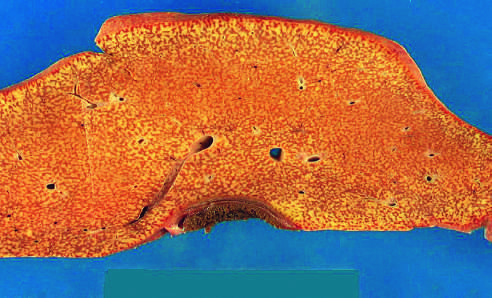what is small (700 g), bile-stained, soft, and congested?
Answer the question using a single word or phrase. The liver 